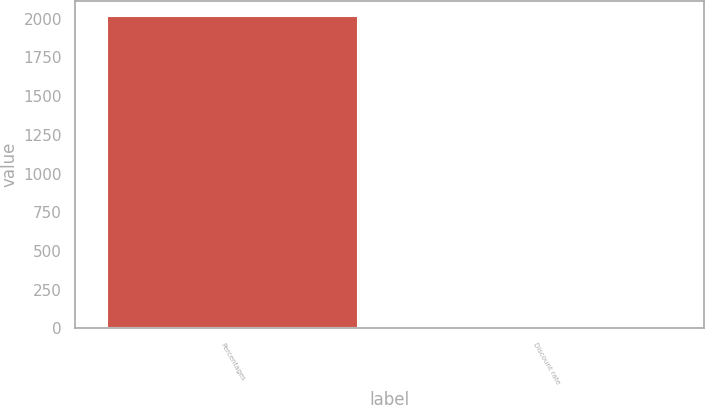<chart> <loc_0><loc_0><loc_500><loc_500><bar_chart><fcel>Percentages<fcel>Discount rate<nl><fcel>2014<fcel>3.74<nl></chart> 